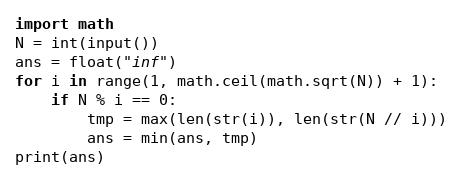<code> <loc_0><loc_0><loc_500><loc_500><_Python_>import math
N = int(input())
ans = float("inf")
for i in range(1, math.ceil(math.sqrt(N)) + 1):
	if N % i == 0:
		tmp = max(len(str(i)), len(str(N // i)))
		ans = min(ans, tmp)
print(ans)
</code> 